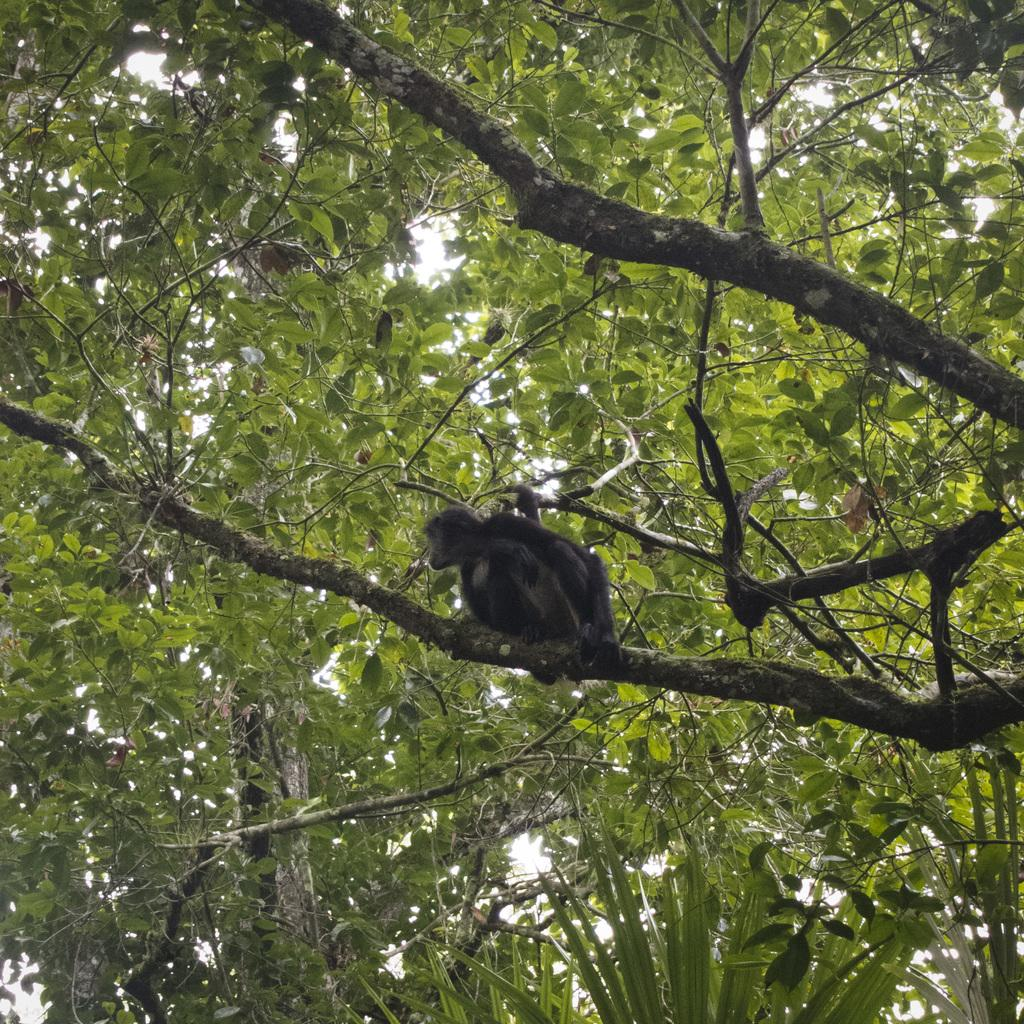What animal is present in the image? There is a monkey in the image. Where is the monkey located? The monkey is on a tree in the image. What other objects or features can be seen in the image? There are trees in the image. What is visible at the top of the image? The sky is visible at the top of the image. How many mountains can be seen in the image? There are no mountains visible in the image; it features a monkey on a tree with trees and the sky in the background. Is the monkey wearing a scarf in the image? There is no scarf present in the image; the monkey is not wearing any clothing or accessories. 